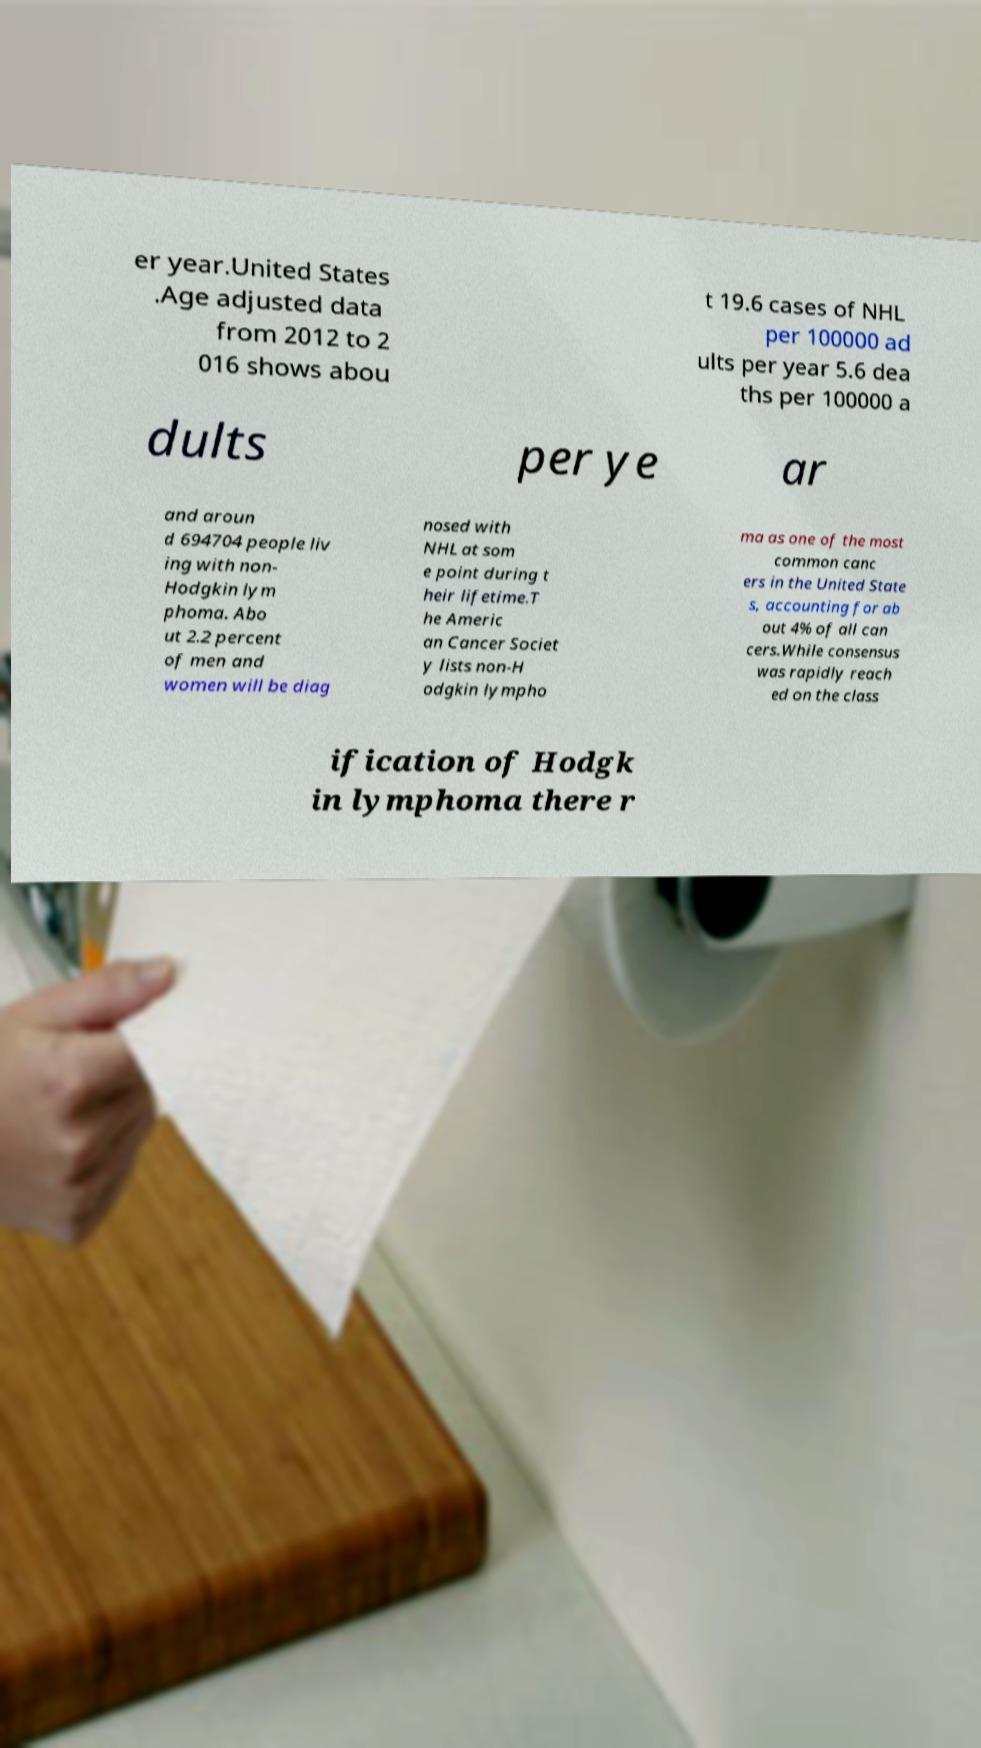Can you accurately transcribe the text from the provided image for me? er year.United States .Age adjusted data from 2012 to 2 016 shows abou t 19.6 cases of NHL per 100000 ad ults per year 5.6 dea ths per 100000 a dults per ye ar and aroun d 694704 people liv ing with non- Hodgkin lym phoma. Abo ut 2.2 percent of men and women will be diag nosed with NHL at som e point during t heir lifetime.T he Americ an Cancer Societ y lists non-H odgkin lympho ma as one of the most common canc ers in the United State s, accounting for ab out 4% of all can cers.While consensus was rapidly reach ed on the class ification of Hodgk in lymphoma there r 